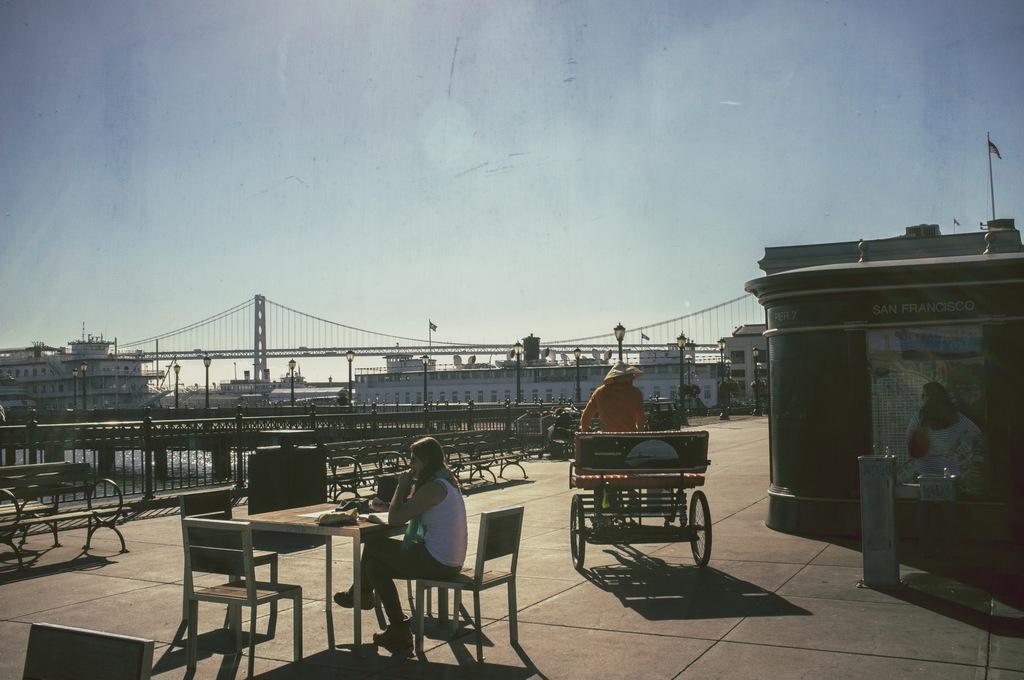Describe this image in one or two sentences. In this image there are two person. One person is riding a vehicle and another is sitting on the chair. There is a table and a bench,at the background there is a building and a bridge. There is a flag and a sky. 